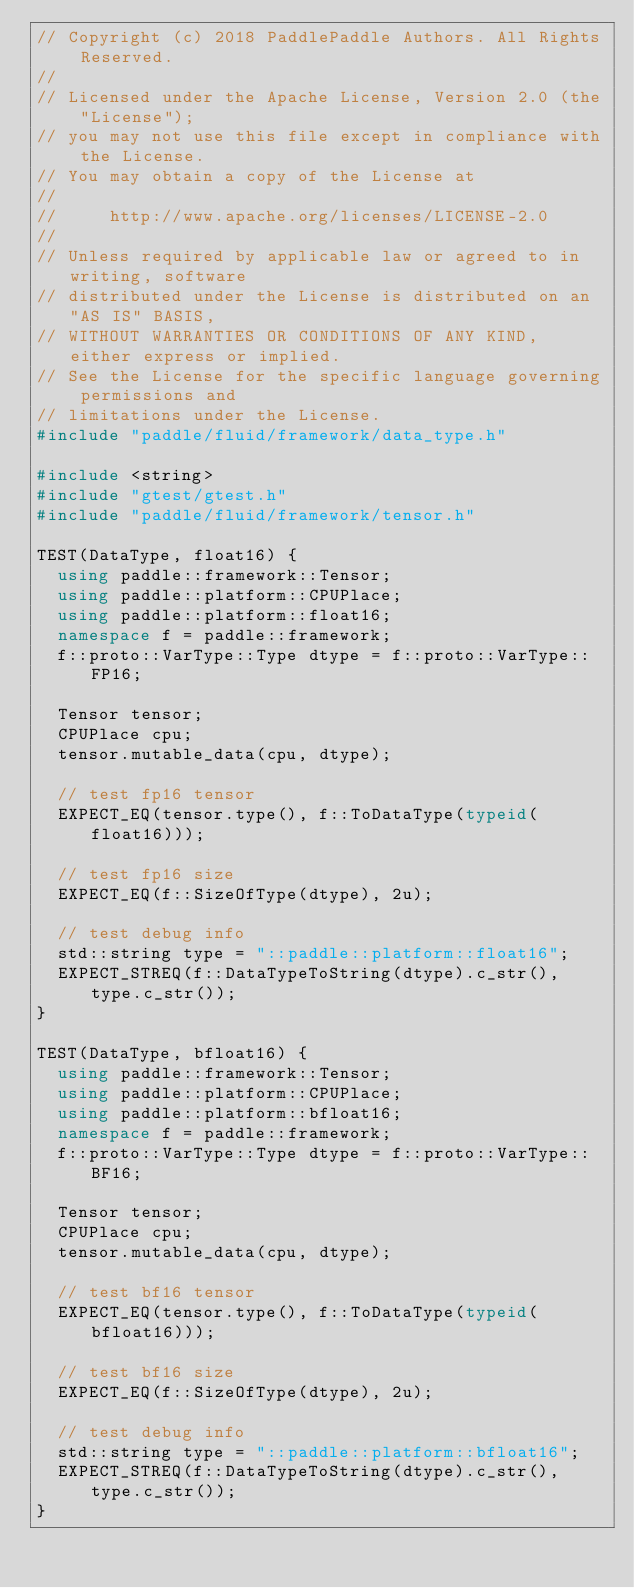Convert code to text. <code><loc_0><loc_0><loc_500><loc_500><_C++_>// Copyright (c) 2018 PaddlePaddle Authors. All Rights Reserved.
//
// Licensed under the Apache License, Version 2.0 (the "License");
// you may not use this file except in compliance with the License.
// You may obtain a copy of the License at
//
//     http://www.apache.org/licenses/LICENSE-2.0
//
// Unless required by applicable law or agreed to in writing, software
// distributed under the License is distributed on an "AS IS" BASIS,
// WITHOUT WARRANTIES OR CONDITIONS OF ANY KIND, either express or implied.
// See the License for the specific language governing permissions and
// limitations under the License.
#include "paddle/fluid/framework/data_type.h"

#include <string>
#include "gtest/gtest.h"
#include "paddle/fluid/framework/tensor.h"

TEST(DataType, float16) {
  using paddle::framework::Tensor;
  using paddle::platform::CPUPlace;
  using paddle::platform::float16;
  namespace f = paddle::framework;
  f::proto::VarType::Type dtype = f::proto::VarType::FP16;

  Tensor tensor;
  CPUPlace cpu;
  tensor.mutable_data(cpu, dtype);

  // test fp16 tensor
  EXPECT_EQ(tensor.type(), f::ToDataType(typeid(float16)));

  // test fp16 size
  EXPECT_EQ(f::SizeOfType(dtype), 2u);

  // test debug info
  std::string type = "::paddle::platform::float16";
  EXPECT_STREQ(f::DataTypeToString(dtype).c_str(), type.c_str());
}

TEST(DataType, bfloat16) {
  using paddle::framework::Tensor;
  using paddle::platform::CPUPlace;
  using paddle::platform::bfloat16;
  namespace f = paddle::framework;
  f::proto::VarType::Type dtype = f::proto::VarType::BF16;

  Tensor tensor;
  CPUPlace cpu;
  tensor.mutable_data(cpu, dtype);

  // test bf16 tensor
  EXPECT_EQ(tensor.type(), f::ToDataType(typeid(bfloat16)));

  // test bf16 size
  EXPECT_EQ(f::SizeOfType(dtype), 2u);

  // test debug info
  std::string type = "::paddle::platform::bfloat16";
  EXPECT_STREQ(f::DataTypeToString(dtype).c_str(), type.c_str());
}
</code> 